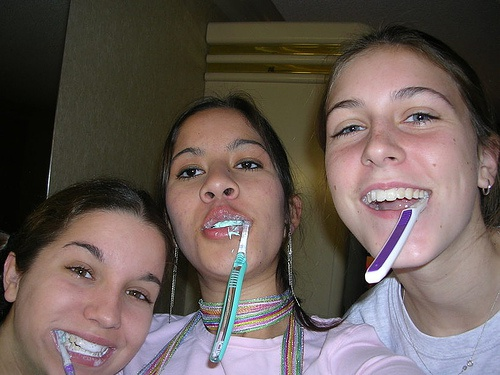Describe the objects in this image and their specific colors. I can see people in black, darkgray, lightpink, and gray tones, people in black, gray, and darkgray tones, people in black, gray, and darkgray tones, toothbrush in black, white, purple, and darkgray tones, and toothbrush in black, gray, darkgray, lavender, and lightblue tones in this image. 